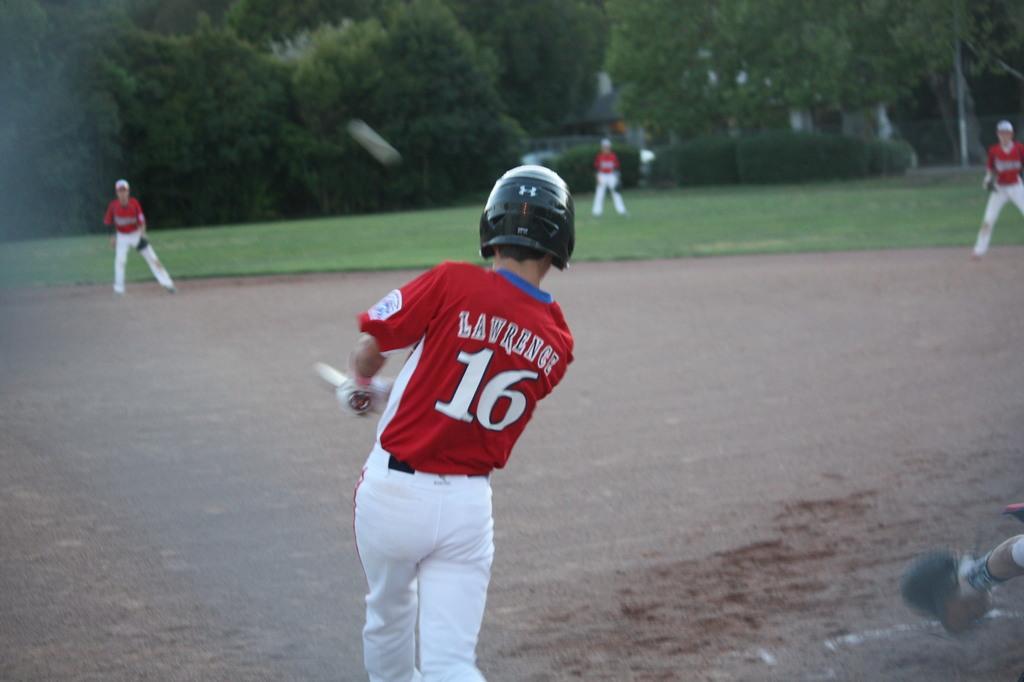In one or two sentences, can you explain what this image depicts? In this image I can see a person standing in the front. He is wearing a helmet, red t shirt and white pant, he is holding a bat in his hands. Other people are standing at the back. There is grass and trees are present at the back. 